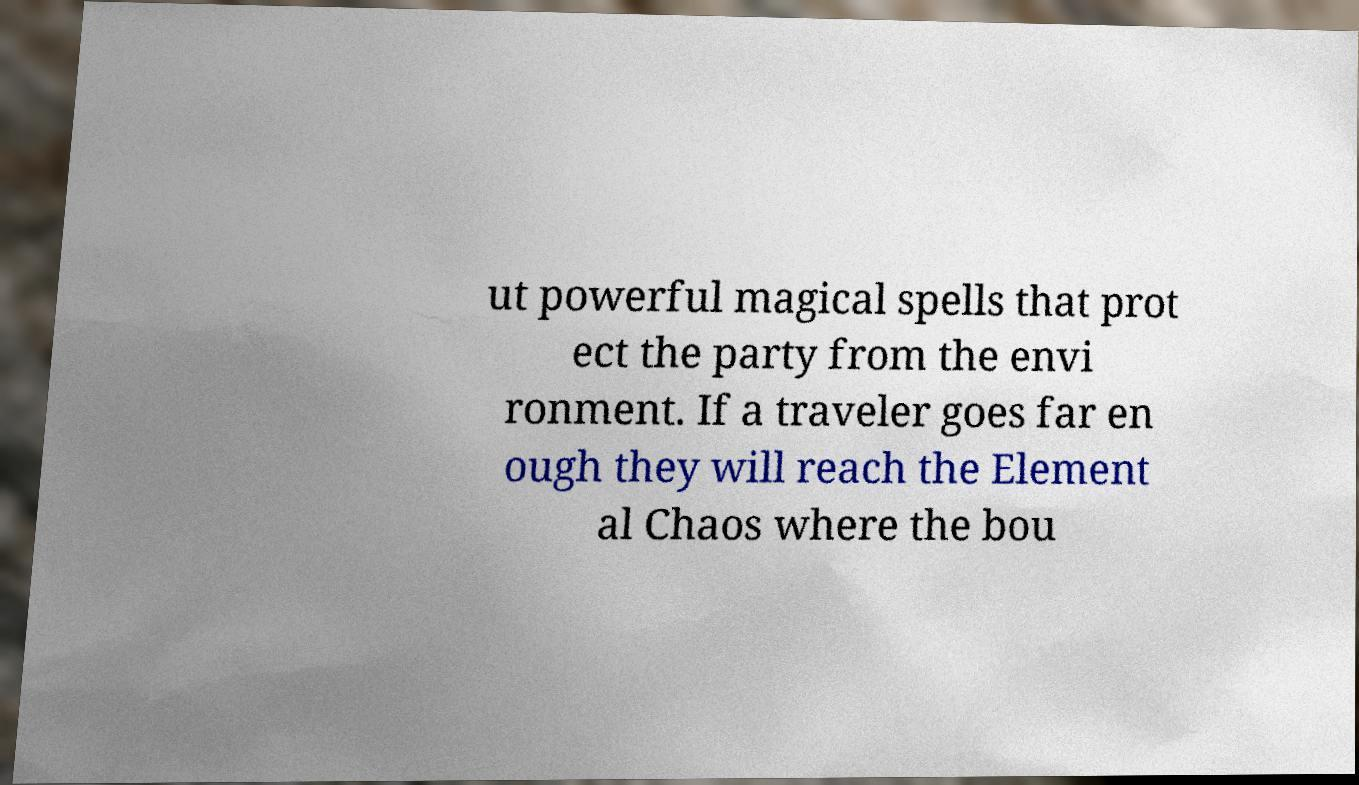Can you read and provide the text displayed in the image?This photo seems to have some interesting text. Can you extract and type it out for me? ut powerful magical spells that prot ect the party from the envi ronment. If a traveler goes far en ough they will reach the Element al Chaos where the bou 